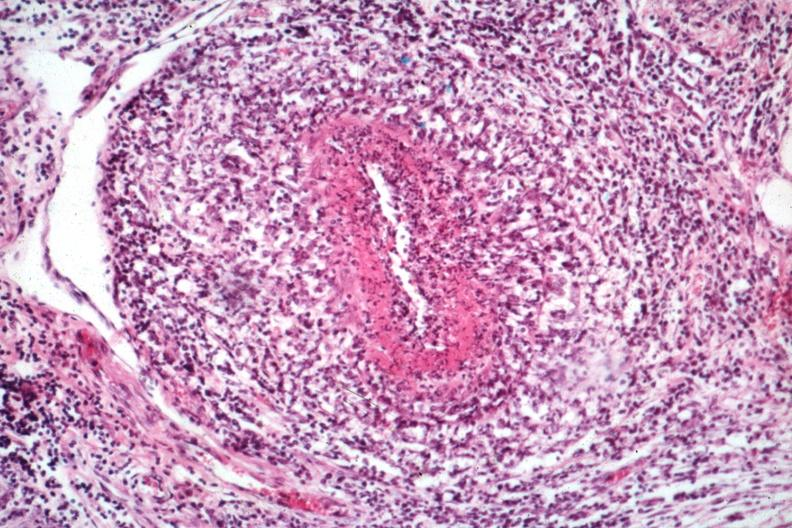s testicle present?
Answer the question using a single word or phrase. Yes 